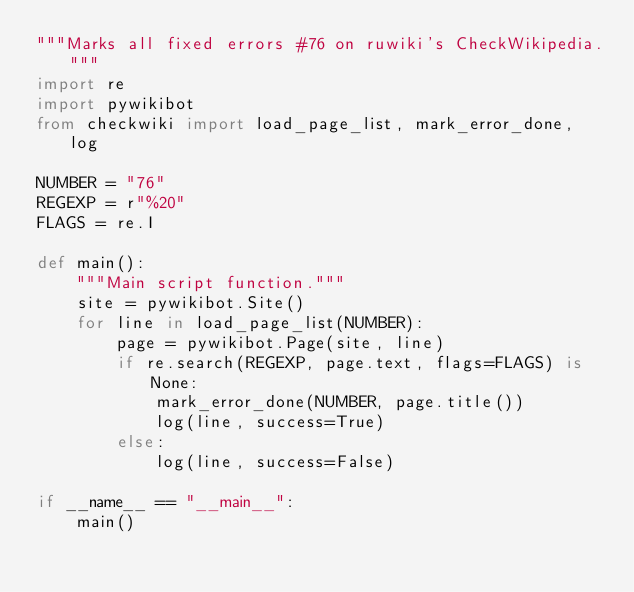Convert code to text. <code><loc_0><loc_0><loc_500><loc_500><_Python_>"""Marks all fixed errors #76 on ruwiki's CheckWikipedia."""
import re
import pywikibot
from checkwiki import load_page_list, mark_error_done, log

NUMBER = "76"
REGEXP = r"%20"
FLAGS = re.I

def main():
    """Main script function."""
    site = pywikibot.Site()
    for line in load_page_list(NUMBER):
        page = pywikibot.Page(site, line)
        if re.search(REGEXP, page.text, flags=FLAGS) is None:
            mark_error_done(NUMBER, page.title())
            log(line, success=True)
        else:
            log(line, success=False)

if __name__ == "__main__":
    main()
</code> 